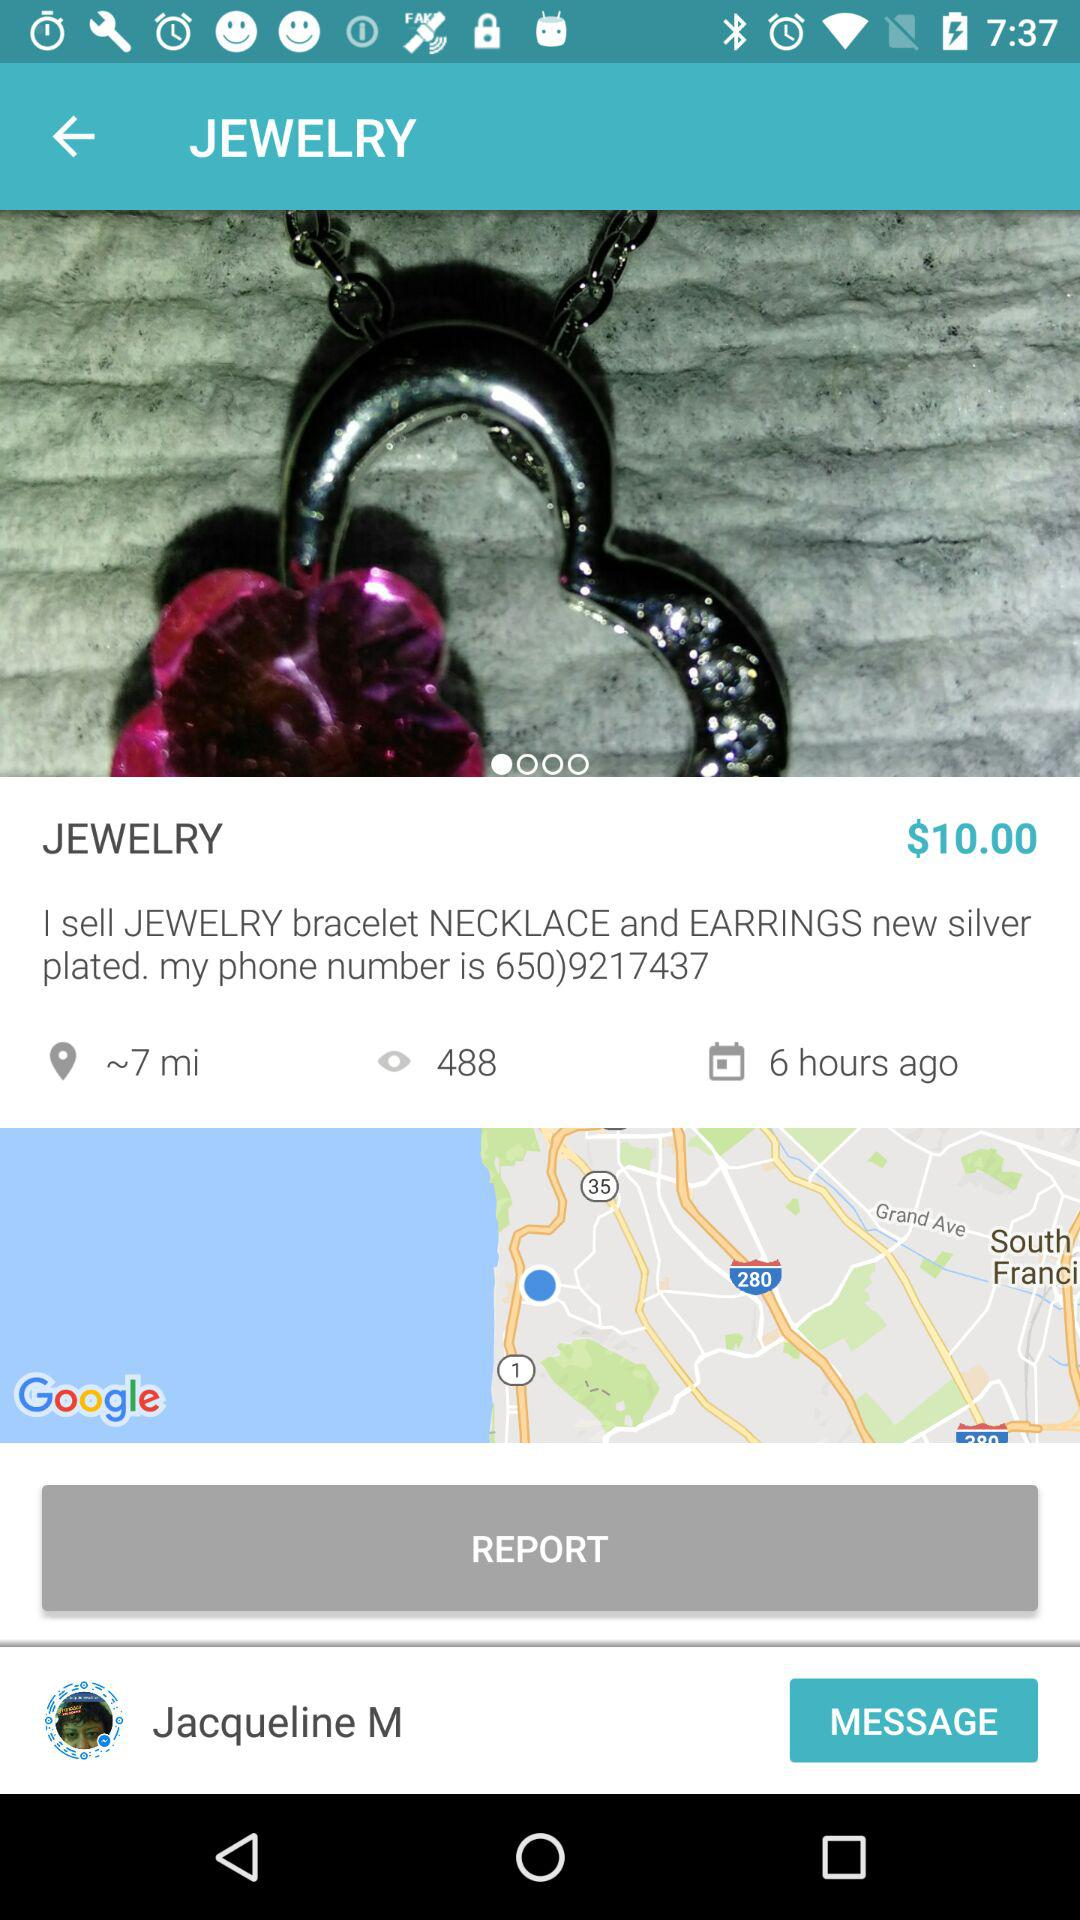How many views are there? There are 488 views. 